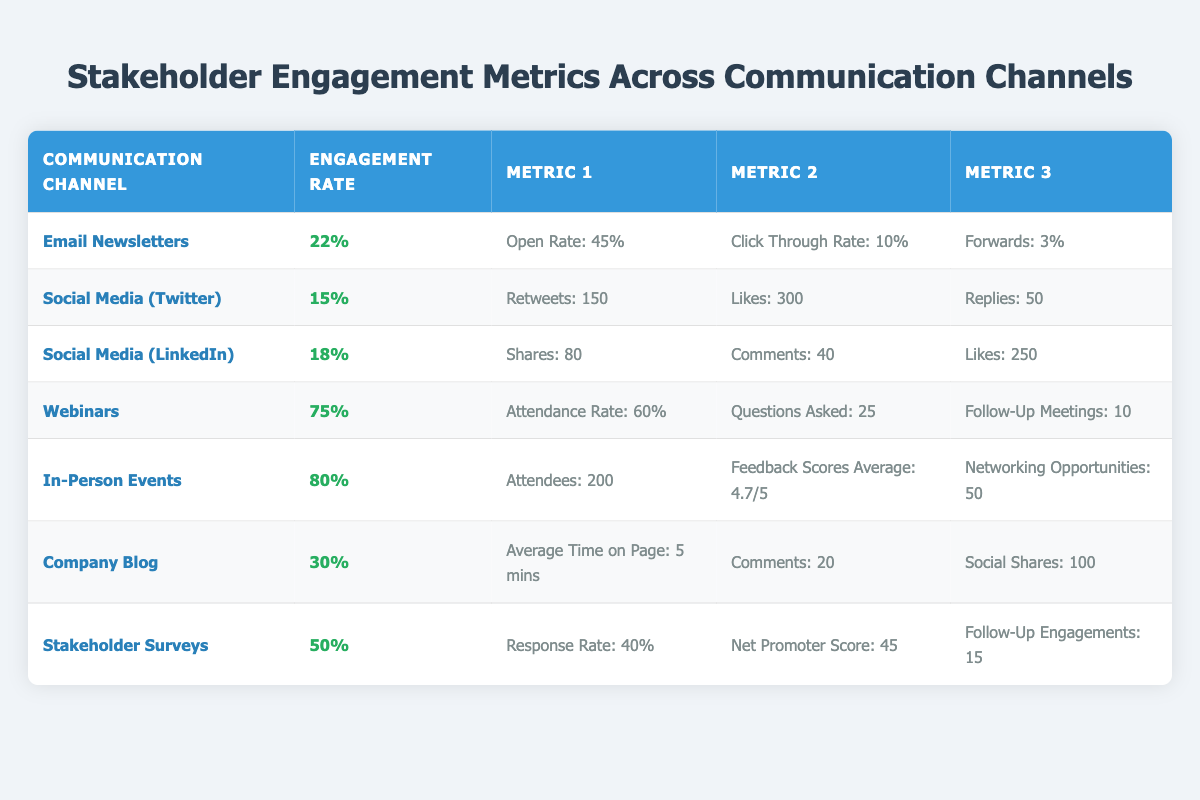What is the engagement rate for Email Newsletters? The table lists the engagement rate for Email Newsletters directly in the corresponding row under the 'Engagement Rate' column, which shows 22%.
Answer: 22% Which communication channel has the highest engagement rate? By examining the 'Engagement Rate' column, In-Person Events shows 80%, which is higher than any other rate in the table.
Answer: In-Person Events What is the average feedback score for In-Person Events? The feedback score for In-Person Events is presented as 4.7/5 in the corresponding row, directly answering the question.
Answer: 4.7/5 How many total likes are garnered from Social Media (Twitter) and Social Media (LinkedIn) combined? The total likes can be found by adding the Likes from both Twitter (300) and LinkedIn (250). So, 300 + 250 = 550.
Answer: 550 Is the average time on page for the Company Blog greater than 4 minutes? The table indicates that the average time on page for the Company Blog is 5 minutes, which is greater than 4 minutes.
Answer: Yes Which communication channel had more than 200 total attendees? Looking at the 'Attendees' metric, In-Person Events lists 200 attendees, which does not exceed 200, while no other channel has attendee numbers listed. Therefore, there are no channels that exceed 200.
Answer: None What percentage of stakeholders responded to the Stakeholder Surveys? From the Stakeholder Surveys row, the Response Rate is listed as 40%, answering the question directly.
Answer: 40% How many questions were asked during the webinars? The number of questions asked during webinars is listed as 25 in the relevant row of the table.
Answer: 25 Which communication channel had the lowest engagement rate? The engagement rates presented in the table show Social Media (Twitter) with a rate of 15%, lower than any other channel listed.
Answer: Social Media (Twitter) 